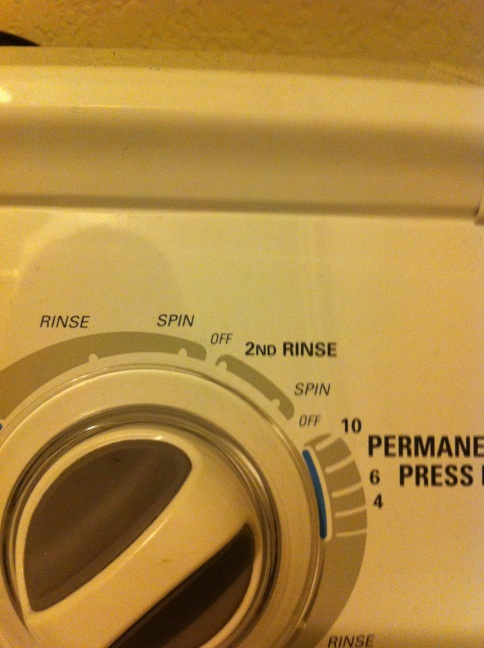Scenario: You have a mixed load of heavily soiled jeans and light cotton shirts. What would be the best settings to use? For a mixed load of heavily soiled jeans and light cotton shirts, you should choose a setting that can handle both types of fabrics effectively. The 'Permanent Press' or 'Regular' cycle is typically a good choice, providing an adequate wash for the jeans while being gentle enough for the cotton shirts. You might also want to use the '2nd Rinse' to ensure all the detergent is thoroughly removed, especially from the heavily soiled jeans. Adjusting the spin speed to medium can balance the needs of the lighter and heavier fabrics. 